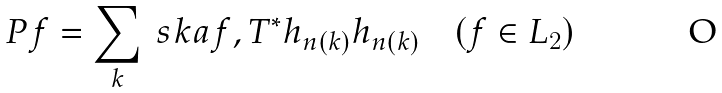Convert formula to latex. <formula><loc_0><loc_0><loc_500><loc_500>P f = \sum _ { k } \ s k a { f , T ^ { * } h _ { n ( k ) } } h _ { n ( k ) } \quad ( f \in L _ { 2 } )</formula> 